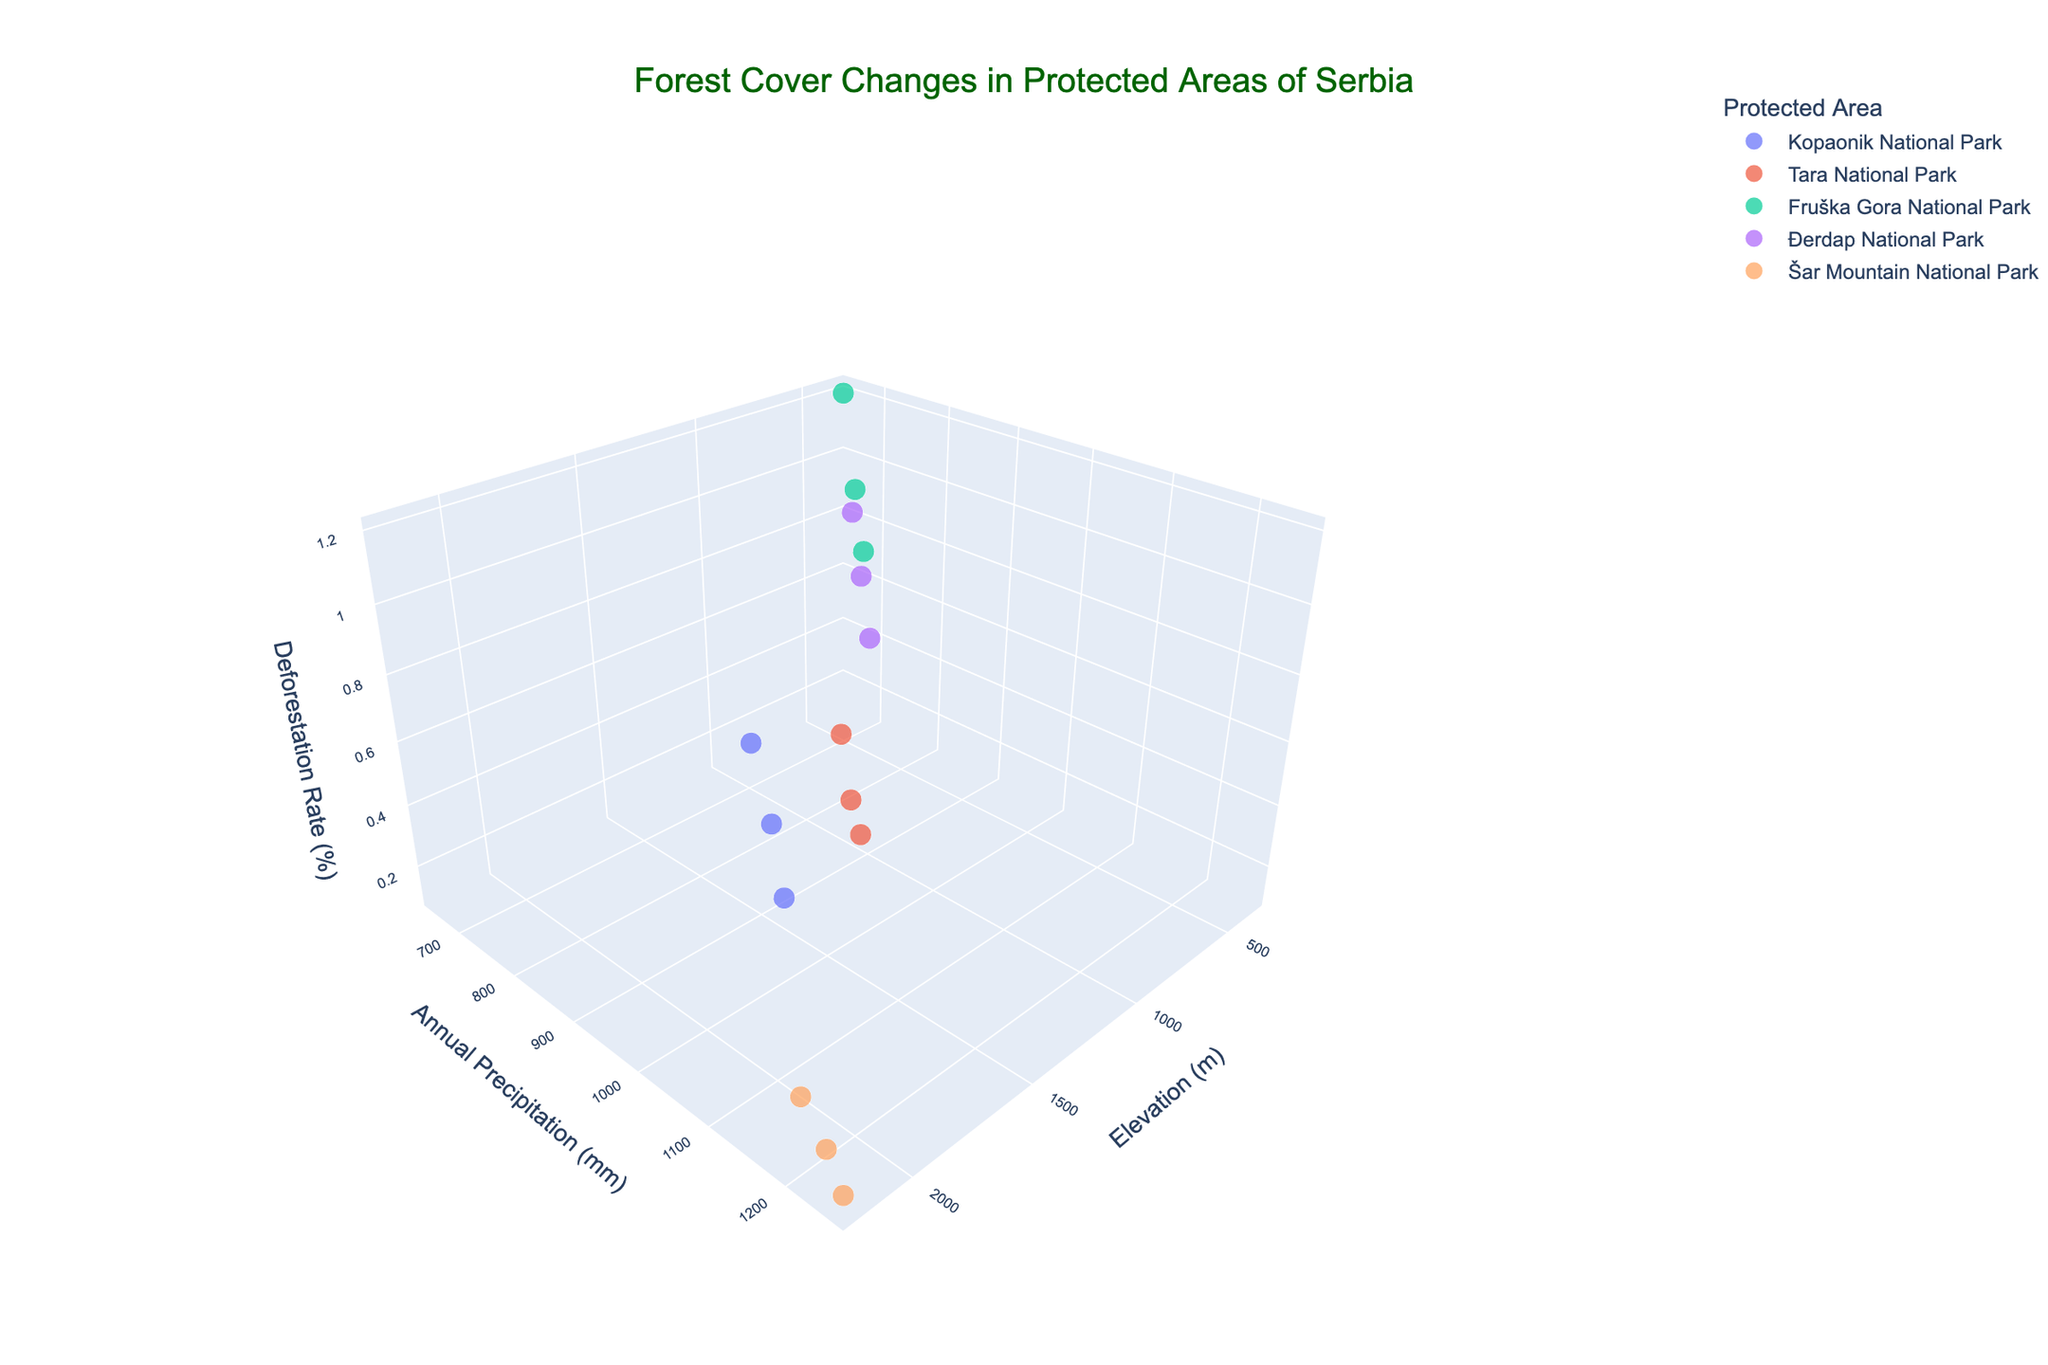Which protected area has the highest elevation? By observing the 'Elevation (m)' axis, the highest point is located at 2200 meters, which corresponds to Šar Mountain National Park.
Answer: Šar Mountain National Park How does the deforestation rate in Kopaonik National Park change from 2000 to 2020? For Kopaonik National Park, the deforestation rate decreases over time: from 0.8% in 2000 to 0.6% in 2010 and then to 0.4% in 2020.
Answer: It decreases Which protected area shows the most decrease in deforestation rate between 2000 and 2020? By comparing all the decreases in deforestation rates for each protected area from 2000 to 2020, Fruška Gora National Park has the largest decrease from 1.2% to 0.7%, a difference of 0.5%.
Answer: Fruška Gora National Park How does the deforestation rate in Đerdap National Park correlate with annual precipitation? In Đerdap National Park, as annual precipitation increases (from 720mm in 2000 to 750mm in 2020), the deforestation rate decreases from 0.9% to 0.5%. This suggests a negative correlation.
Answer: It shows a negative correlation Which protected area has the smallest change in precipitation from 2000 to 2020? By calculating and comparing the changes in annual precipitation for each protected area, Kopaonik National Park has the smallest change, increasing only from 985 mm to 1025 mm, a difference of 40 mm.
Answer: Kopaonik National Park What is the trend in deforestation rates across all protected areas from 2000 to 2020? By observing the z-axis (deforestation rates) for each protected area over the years, it is evident that the deforestation rates generally trend downwards over time in all protected areas.
Answer: Downward trend Compare the deforestation rate in Tara National Park and Fruška Gora National Park in 2020. In 2020, Tara National Park has a deforestation rate of 0.2%, while Fruška Gora National Park has a deforestation rate of 0.7%. Therefore, Fruška Gora National Park has a higher deforestation rate.
Answer: Fruška Gora National Park has a higher rate Which years are represented by the largest and smallest marker sizes in the plot? The size of the markers in the plot represents the years, with 2020 having the largest markers and 2000 having the smallest markers.
Answer: 2020 is the largest, 2000 is the smallest What relationship can you infer between deforestation rate and elevation in the plot? Observing the plot, it appears that higher elevations (e.g., Šar Mountain National Park at 2200m) tend to have lower deforestation rates, while lower elevations (e.g., Fruška Gora National Park at 350m) tend to have higher rates.
Answer: Higher elevation tends to have lower deforestation rates Which protected area experienced the highest increase in annual precipitation from 2000 to 2020? By comparing the precipitation changes for each protected area, Šar Mountain National Park experienced the highest increase, from 1200 mm in 2000 to 1250 mm in 2020, an increase of 50 mm.
Answer: Šar Mountain National Park 